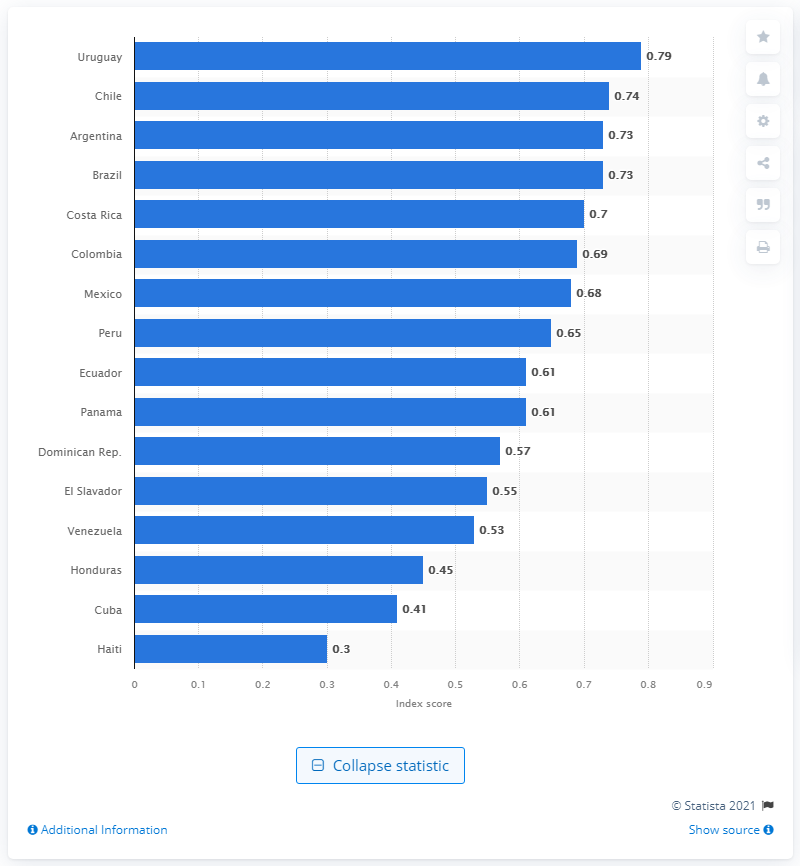Give some essential details in this illustration. Uruguay had a very high EGDI rating, making it a standout country in terms of overall well-being and quality of life. Haiti's EGDI score was 0.3. 